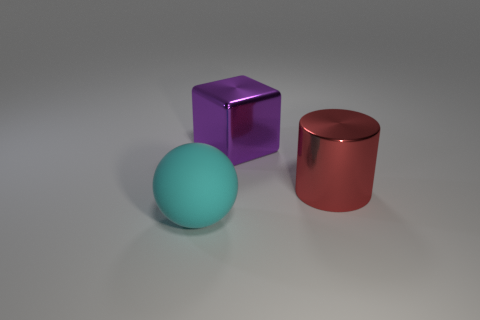What is the shape of the cyan thing?
Your answer should be very brief. Sphere. How many red cylinders have the same material as the cyan sphere?
Ensure brevity in your answer.  0. There is another thing that is the same material as the big purple thing; what color is it?
Offer a terse response. Red. Is the size of the purple block the same as the object that is in front of the red object?
Provide a succinct answer. Yes. What is the big thing to the left of the big thing behind the thing that is right of the big purple shiny object made of?
Ensure brevity in your answer.  Rubber. How many objects are big cyan matte things or large gray metal cylinders?
Provide a short and direct response. 1. There is a big metallic object that is behind the red shiny cylinder; is it the same color as the big object that is in front of the large red cylinder?
Provide a short and direct response. No. What is the shape of the red metallic object that is the same size as the purple shiny cube?
Your answer should be compact. Cylinder. How many things are either big shiny objects behind the large red object or big objects that are behind the large cyan matte object?
Your answer should be compact. 2. Is the number of large blocks less than the number of shiny things?
Give a very brief answer. Yes. 